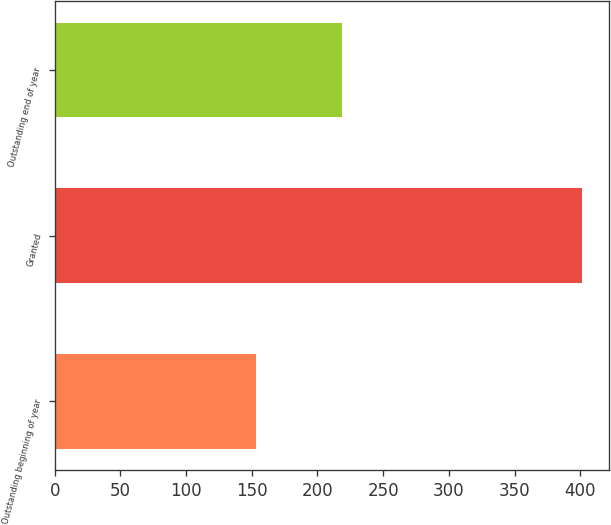Convert chart. <chart><loc_0><loc_0><loc_500><loc_500><bar_chart><fcel>Outstanding beginning of year<fcel>Granted<fcel>Outstanding end of year<nl><fcel>153.4<fcel>401.56<fcel>218.34<nl></chart> 